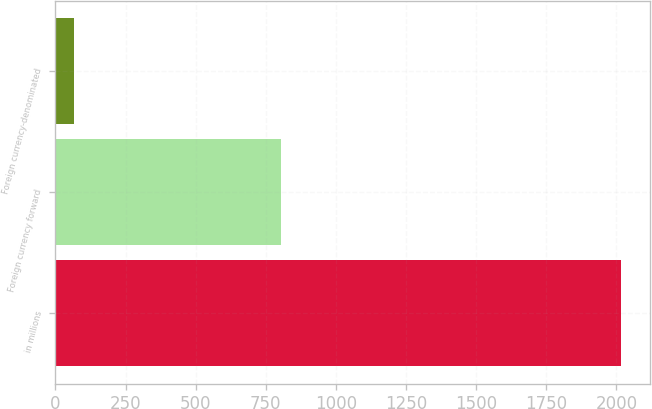Convert chart to OTSL. <chart><loc_0><loc_0><loc_500><loc_500><bar_chart><fcel>in millions<fcel>Foreign currency forward<fcel>Foreign currency-denominated<nl><fcel>2017<fcel>805<fcel>67<nl></chart> 